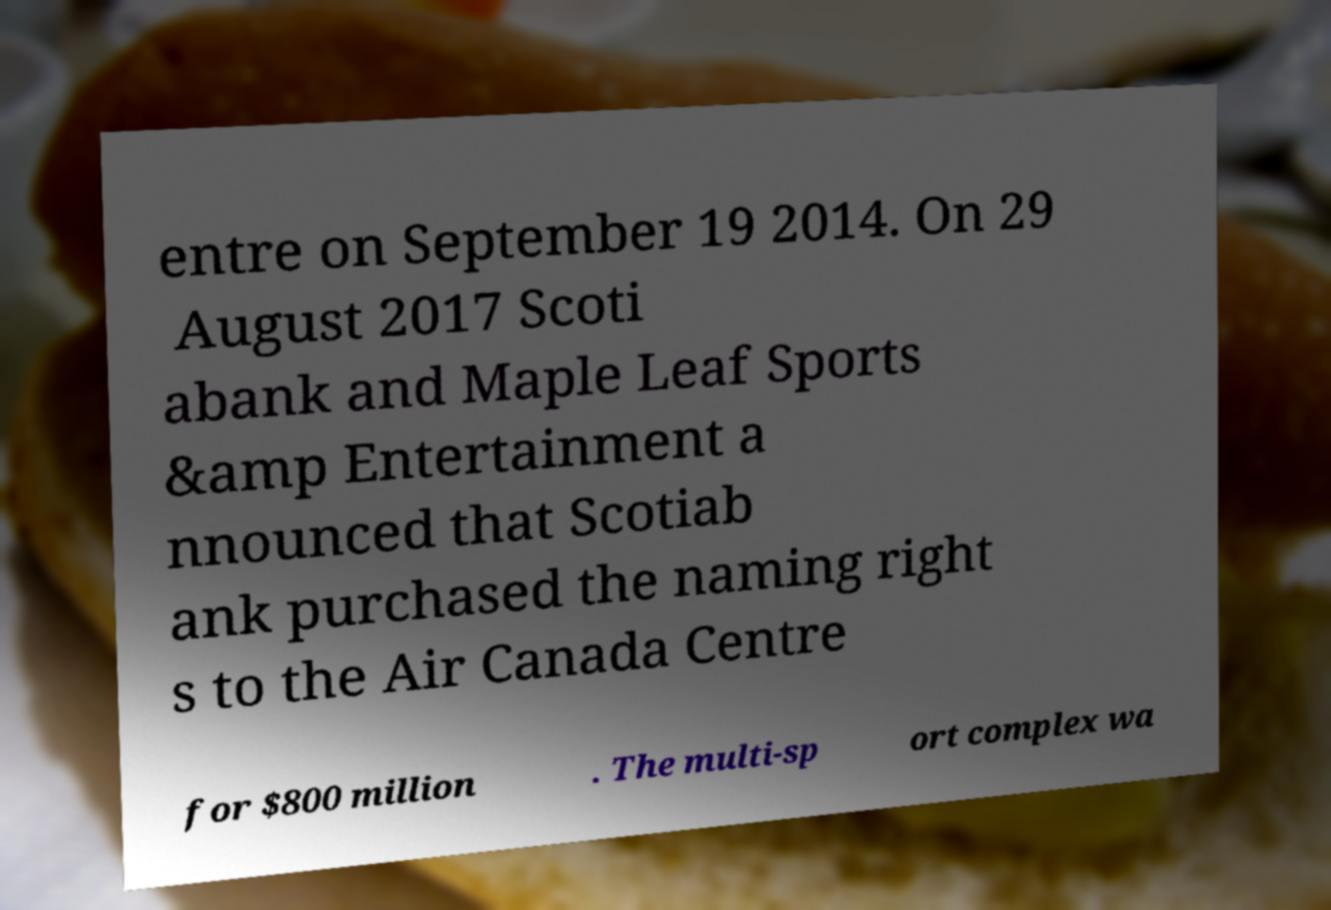Please identify and transcribe the text found in this image. entre on September 19 2014. On 29 August 2017 Scoti abank and Maple Leaf Sports &amp Entertainment a nnounced that Scotiab ank purchased the naming right s to the Air Canada Centre for $800 million . The multi-sp ort complex wa 